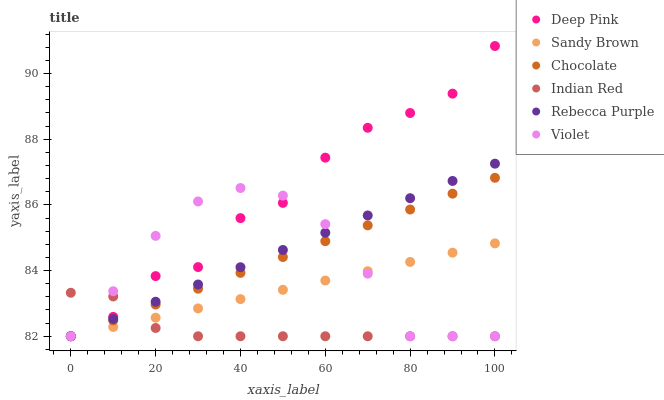Does Indian Red have the minimum area under the curve?
Answer yes or no. Yes. Does Deep Pink have the maximum area under the curve?
Answer yes or no. Yes. Does Chocolate have the minimum area under the curve?
Answer yes or no. No. Does Chocolate have the maximum area under the curve?
Answer yes or no. No. Is Rebecca Purple the smoothest?
Answer yes or no. Yes. Is Deep Pink the roughest?
Answer yes or no. Yes. Is Chocolate the smoothest?
Answer yes or no. No. Is Chocolate the roughest?
Answer yes or no. No. Does Deep Pink have the lowest value?
Answer yes or no. Yes. Does Deep Pink have the highest value?
Answer yes or no. Yes. Does Chocolate have the highest value?
Answer yes or no. No. Does Chocolate intersect Sandy Brown?
Answer yes or no. Yes. Is Chocolate less than Sandy Brown?
Answer yes or no. No. Is Chocolate greater than Sandy Brown?
Answer yes or no. No. 